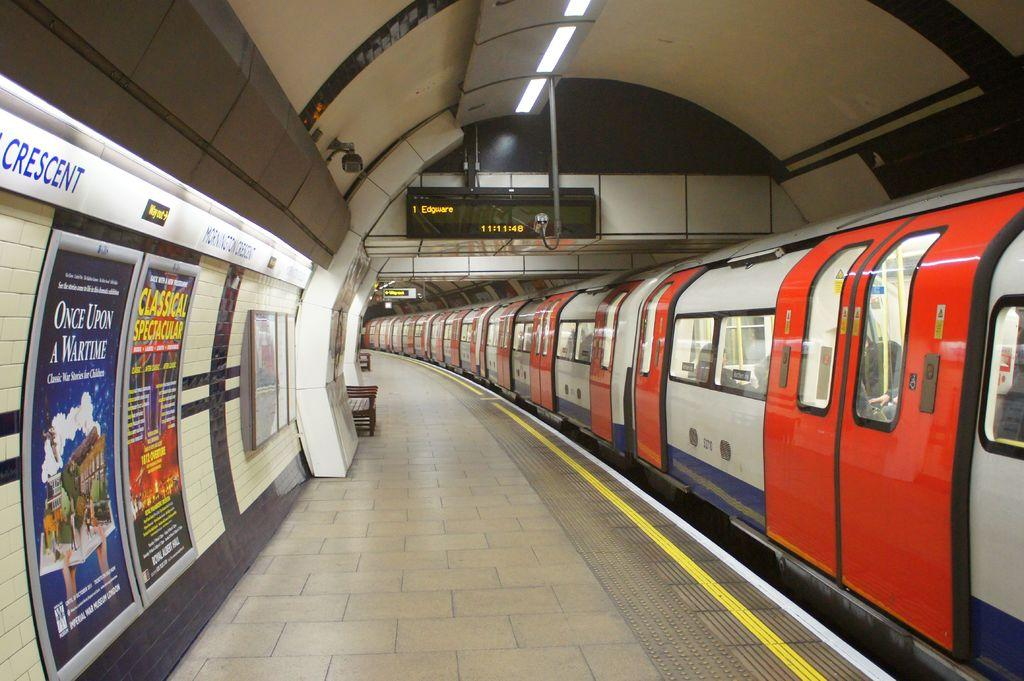<image>
Give a short and clear explanation of the subsequent image. A train station clock shows the time as 11:11:48 